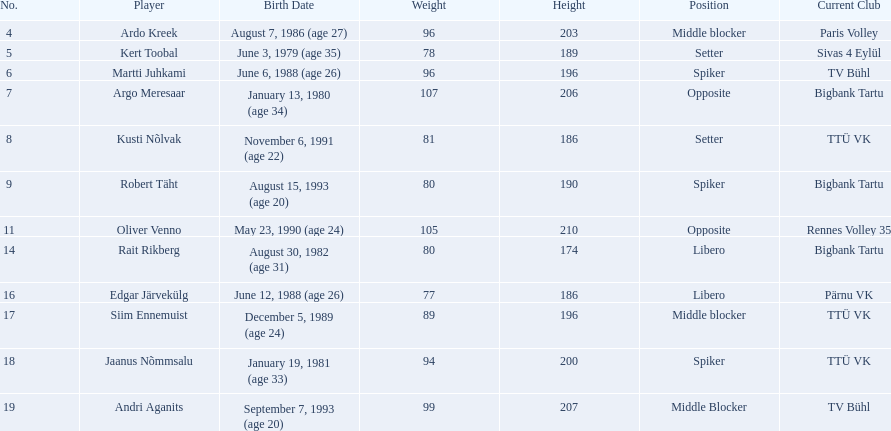Who are all the participants? Ardo Kreek, Kert Toobal, Martti Juhkami, Argo Meresaar, Kusti Nõlvak, Robert Täht, Oliver Venno, Rait Rikberg, Edgar Järvekülg, Siim Ennemuist, Jaanus Nõmmsalu, Andri Aganits. What are their heights? 203, 189, 196, 206, 186, 190, 210, 174, 186, 196, 200, 207. And who is the tallest among them? Oliver Venno. 